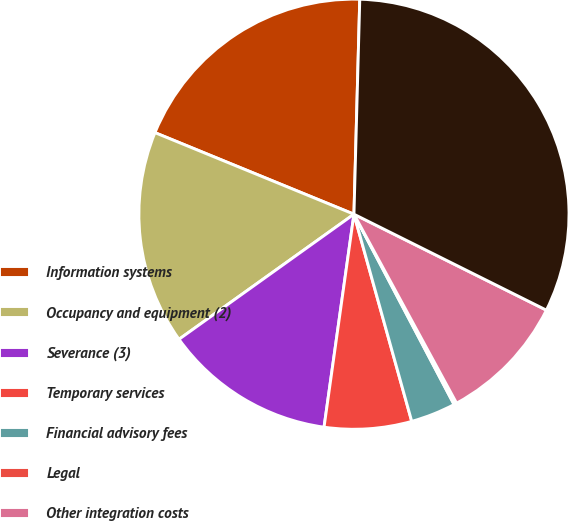<chart> <loc_0><loc_0><loc_500><loc_500><pie_chart><fcel>Information systems<fcel>Occupancy and equipment (2)<fcel>Severance (3)<fcel>Temporary services<fcel>Financial advisory fees<fcel>Legal<fcel>Other integration costs<fcel>Total acquisition related<nl><fcel>19.24%<fcel>16.07%<fcel>12.9%<fcel>6.55%<fcel>3.38%<fcel>0.21%<fcel>9.72%<fcel>31.93%<nl></chart> 